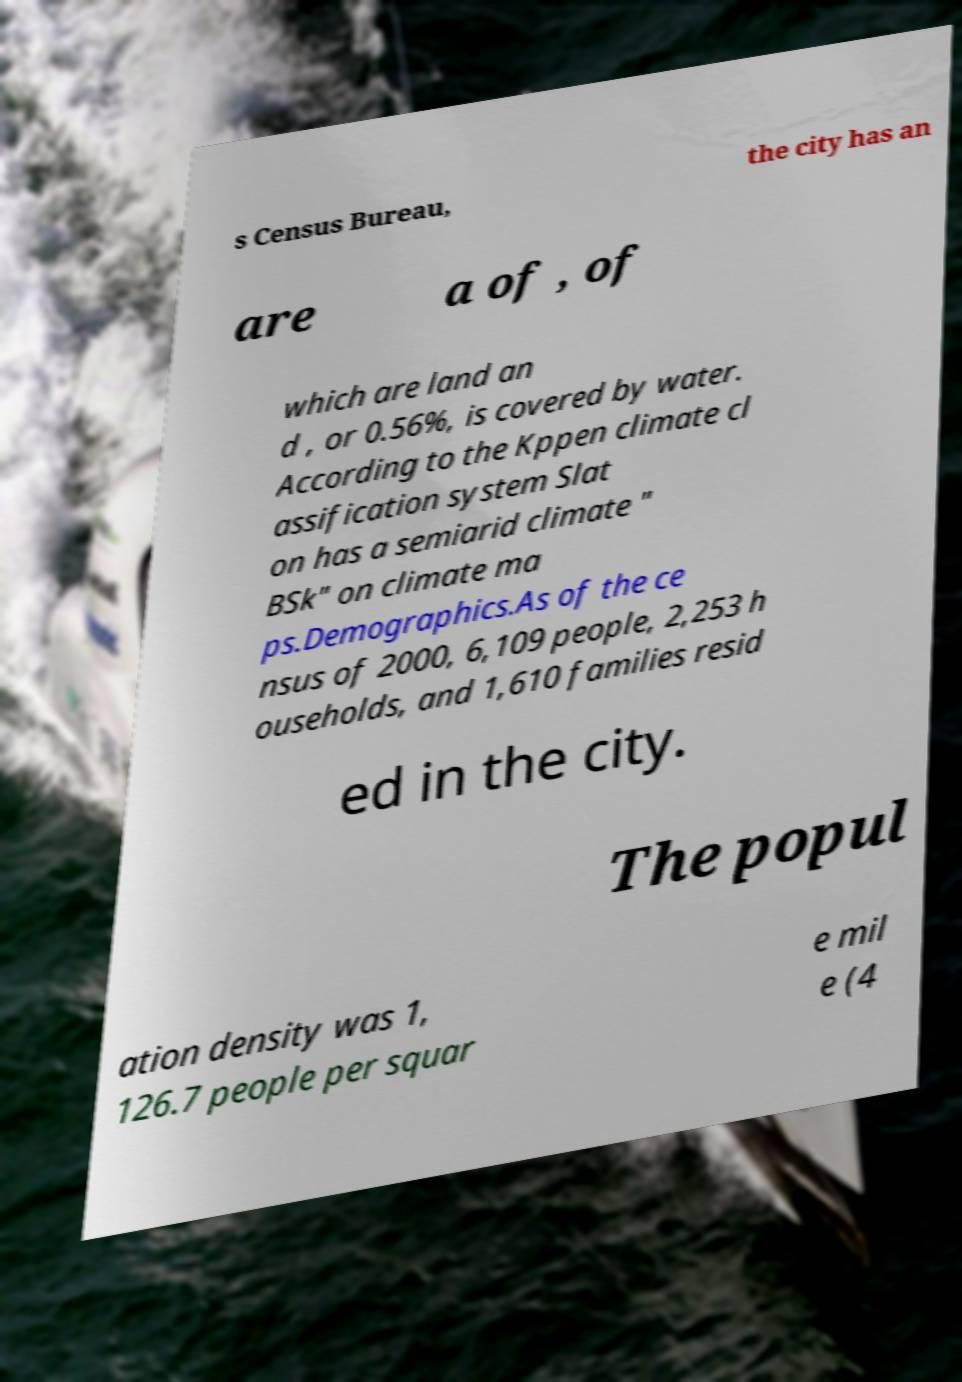For documentation purposes, I need the text within this image transcribed. Could you provide that? s Census Bureau, the city has an are a of , of which are land an d , or 0.56%, is covered by water. According to the Kppen climate cl assification system Slat on has a semiarid climate " BSk" on climate ma ps.Demographics.As of the ce nsus of 2000, 6,109 people, 2,253 h ouseholds, and 1,610 families resid ed in the city. The popul ation density was 1, 126.7 people per squar e mil e (4 